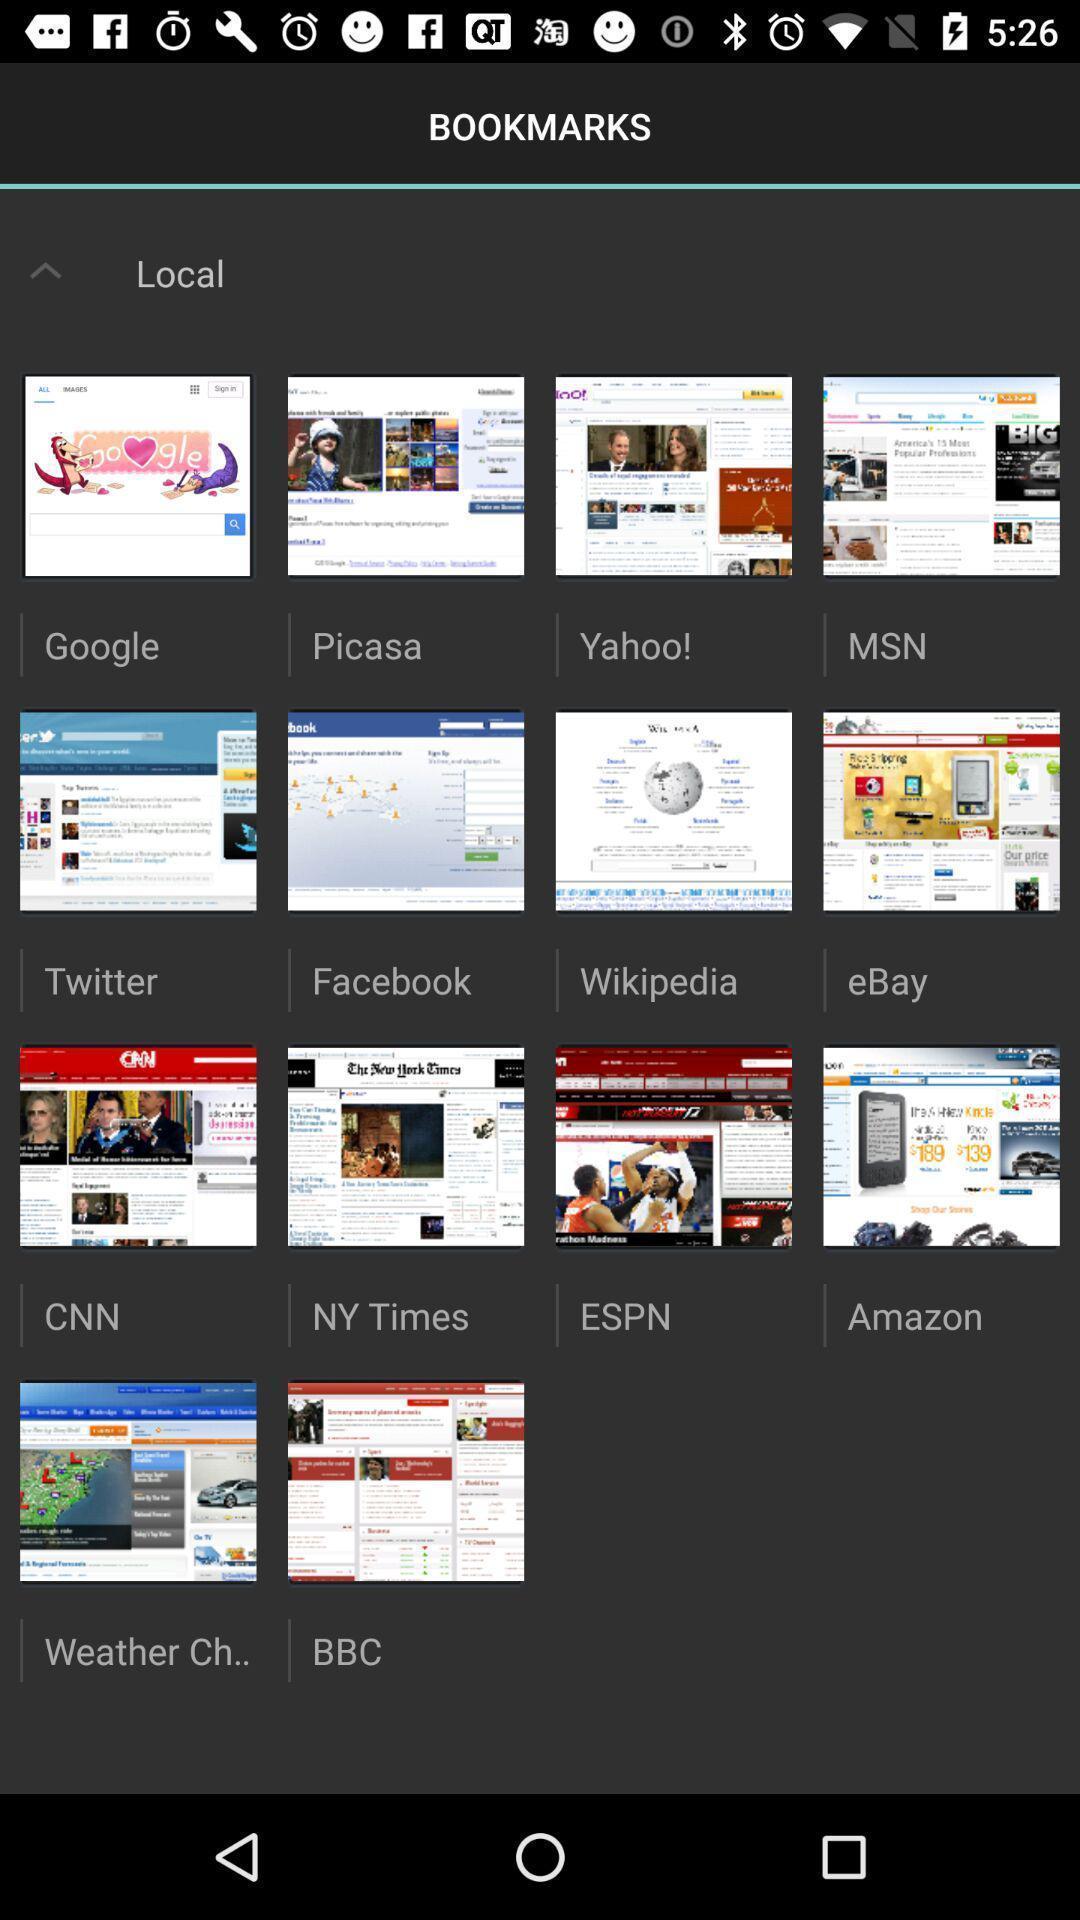Explain what's happening in this screen capture. Screen showing bookmarks. 